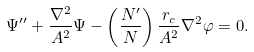Convert formula to latex. <formula><loc_0><loc_0><loc_500><loc_500>\Psi ^ { \prime \prime } + \frac { \nabla ^ { 2 } } { A ^ { 2 } } \Psi - \left ( \frac { N ^ { \prime } } { N } \right ) \frac { r _ { c } } { A ^ { 2 } } \nabla ^ { 2 } \varphi = 0 .</formula> 